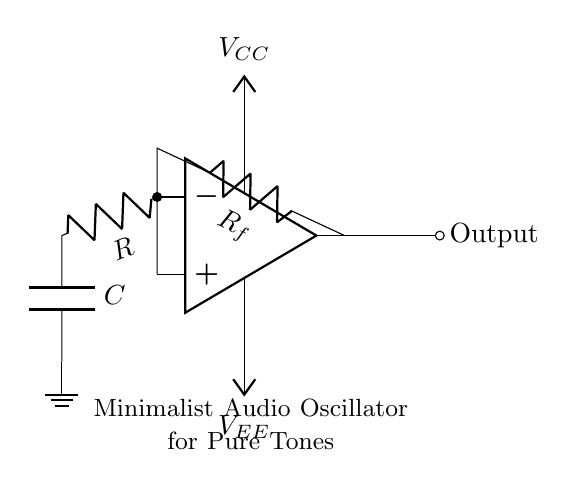What is the type of circuit depicted? The circuit is an audio oscillator, which is designed to generate pure tones. This is indicated by the labels and the arrangement of components like the op-amp, resistor, and capacitor.
Answer: audio oscillator What components are utilized in feedback? The feedback network in the circuit includes a resistor labeled Rf that connects the output of the op-amp back to its non-inverting input. This configuration is essential for maintaining oscillation by providing the necessary feedback.
Answer: Rf What does the capacitor represent in this circuit? The capacitor labeled C is part of the RC timing network, which determines the oscillation frequency. Its charge and discharge characteristics influence the sound wave produced by the oscillator, defining the tone.
Answer: C How many power supply voltages are present? There are two supply voltages indicated: Vcc and Vee. Vcc provides a positive voltage to the op-amp, while Vee provides a negative voltage, allowing the op-amp to operate in a dual-supply mode.
Answer: two What role does the resistor labeled R serve? The resistor R is part of the timing network in conjunction with the capacitor C. It influences the charging time of the capacitor, thus affecting the frequency of oscillation and the tone generated by the circuit.
Answer: R What is the final output of this circuit? The output is indicated by the connection marked Output on the right side of the op-amp. It delivers the generated audio signal, which can be sent to speakers or other devices for sound art installations.
Answer: Output 